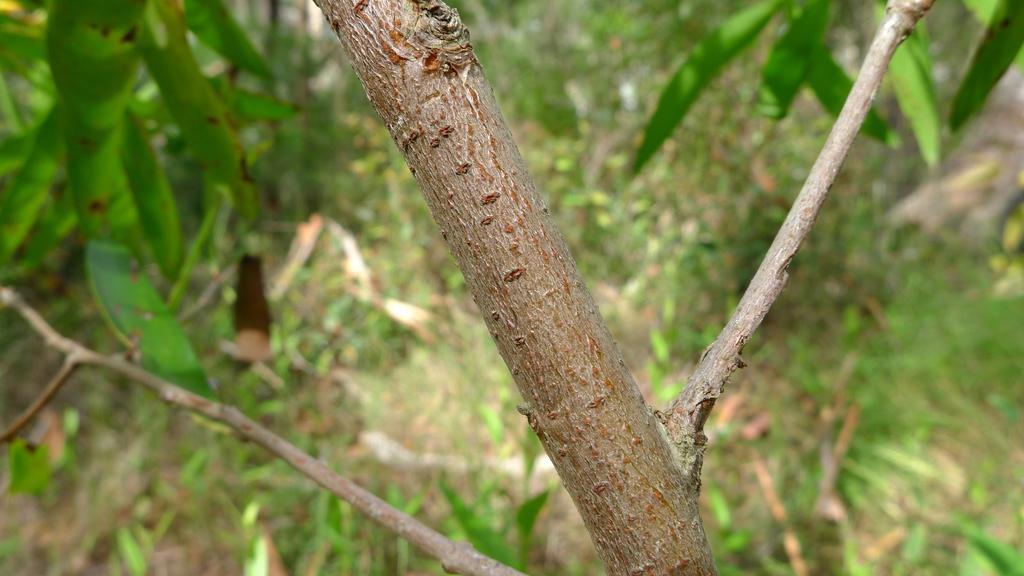Could you give a brief overview of what you see in this image? In the foreground of the image there is a tree branch and stems. In the background of the image there are leaves. 